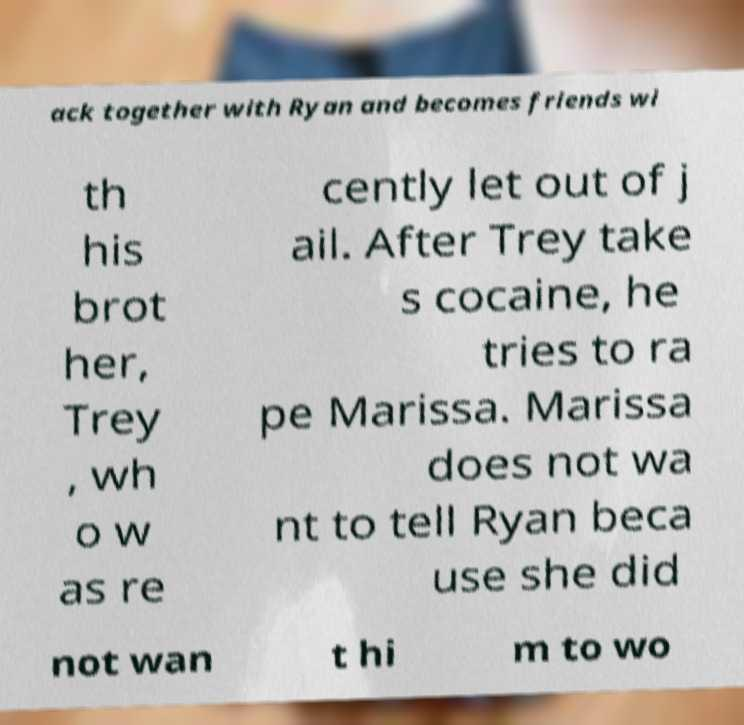Could you extract and type out the text from this image? ack together with Ryan and becomes friends wi th his brot her, Trey , wh o w as re cently let out of j ail. After Trey take s cocaine, he tries to ra pe Marissa. Marissa does not wa nt to tell Ryan beca use she did not wan t hi m to wo 